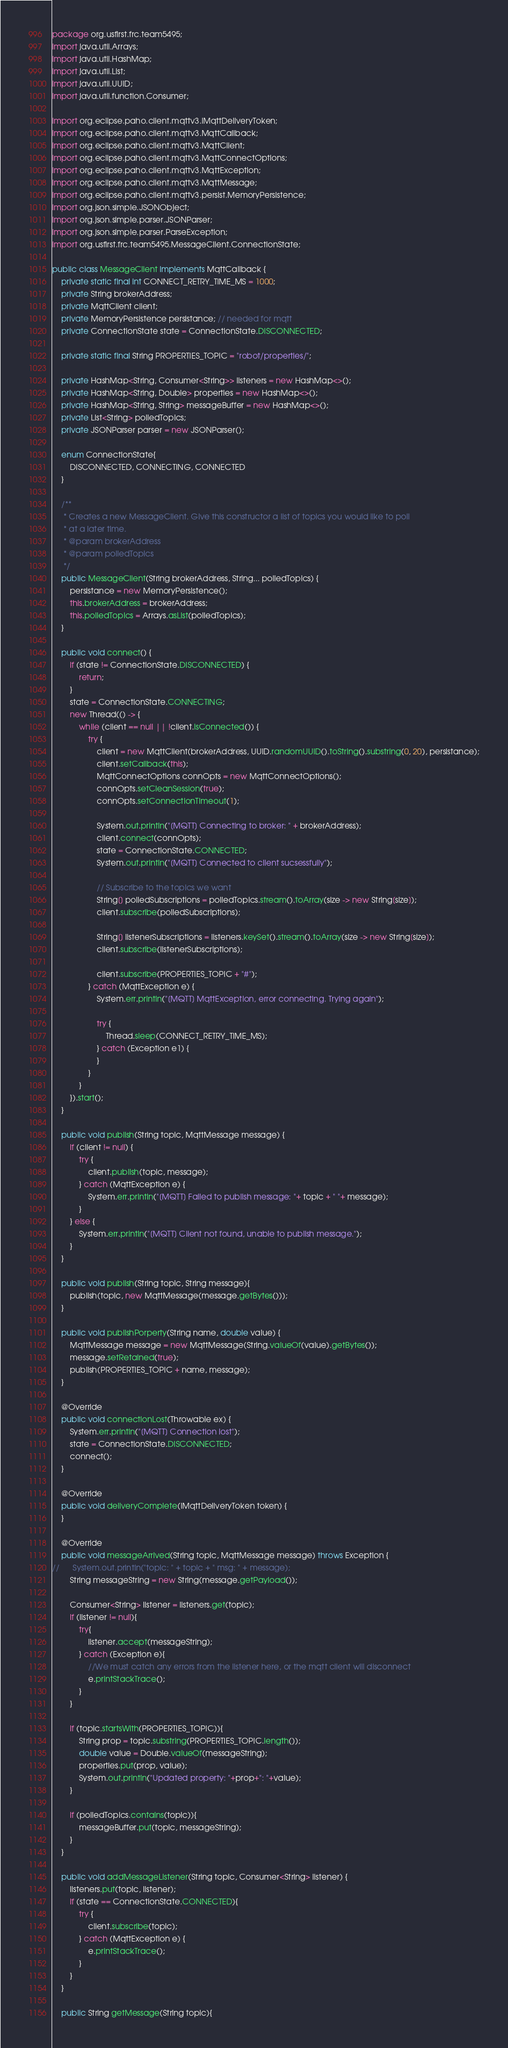<code> <loc_0><loc_0><loc_500><loc_500><_Java_>package org.usfirst.frc.team5495;
import java.util.Arrays;
import java.util.HashMap;
import java.util.List;
import java.util.UUID;
import java.util.function.Consumer;

import org.eclipse.paho.client.mqttv3.IMqttDeliveryToken;
import org.eclipse.paho.client.mqttv3.MqttCallback;
import org.eclipse.paho.client.mqttv3.MqttClient;
import org.eclipse.paho.client.mqttv3.MqttConnectOptions;
import org.eclipse.paho.client.mqttv3.MqttException;
import org.eclipse.paho.client.mqttv3.MqttMessage;
import org.eclipse.paho.client.mqttv3.persist.MemoryPersistence;
import org.json.simple.JSONObject;
import org.json.simple.parser.JSONParser;
import org.json.simple.parser.ParseException;
import org.usfirst.frc.team5495.MessageClient.ConnectionState;

public class MessageClient implements MqttCallback {
	private static final int CONNECT_RETRY_TIME_MS = 1000;
	private String brokerAddress;
	private MqttClient client;
	private MemoryPersistence persistance; // needed for mqtt
	private ConnectionState state = ConnectionState.DISCONNECTED;
	
	private static final String PROPERTIES_TOPIC = "robot/properties/";
	
	private HashMap<String, Consumer<String>> listeners = new HashMap<>();
	private HashMap<String, Double> properties = new HashMap<>();
	private HashMap<String, String> messageBuffer = new HashMap<>();
	private List<String> polledTopics;
	private JSONParser parser = new JSONParser();

	enum ConnectionState{
		DISCONNECTED, CONNECTING, CONNECTED
	}
	
	/**
	 * Creates a new MessageClient. Give this constructor a list of topics you would like to poll 
	 * at a later time.
	 * @param brokerAddress
	 * @param polledTopics
	 */
	public MessageClient(String brokerAddress, String... polledTopics) {
		persistance = new MemoryPersistence();
		this.brokerAddress = brokerAddress;
		this.polledTopics = Arrays.asList(polledTopics);
	}

	public void connect() {
		if (state != ConnectionState.DISCONNECTED) {
			return;
		}
		state = ConnectionState.CONNECTING;
		new Thread(() -> {
			while (client == null || !client.isConnected()) {
				try {
					client = new MqttClient(brokerAddress, UUID.randomUUID().toString().substring(0, 20), persistance);
					client.setCallback(this);
					MqttConnectOptions connOpts = new MqttConnectOptions();
					connOpts.setCleanSession(true);
					connOpts.setConnectionTimeout(1);
					
					System.out.println("[MQTT] Connecting to broker: " + brokerAddress);
					client.connect(connOpts);
					state = ConnectionState.CONNECTED;
					System.out.println("[MQTT] Connected to client sucsessfully");

					// Subscribe to the topics we want
					String[] polledSubscriptions = polledTopics.stream().toArray(size -> new String[size]);
					client.subscribe(polledSubscriptions);
					
					String[] listenerSubscriptions = listeners.keySet().stream().toArray(size -> new String[size]);
					client.subscribe(listenerSubscriptions);

					client.subscribe(PROPERTIES_TOPIC + "#");
				} catch (MqttException e) {
					System.err.println("[MQTT] MqttException, error connecting. Trying again");
					
					try {
						Thread.sleep(CONNECT_RETRY_TIME_MS);
					} catch (Exception e1) {
					}
				}
			}
		}).start();
	}

	public void publish(String topic, MqttMessage message) {
		if (client != null) {
			try {
				client.publish(topic, message);
			} catch (MqttException e) {
				System.err.println("[MQTT] Failed to publish message: "+ topic + " "+ message);
			}
		} else {
			System.err.println("[MQTT] Client not found, unable to publish message.");
		}
	}
	
	public void publish(String topic, String message){
		publish(topic, new MqttMessage(message.getBytes()));
	}

	public void publishPorperty(String name, double value) {
		MqttMessage message = new MqttMessage(String.valueOf(value).getBytes());
		message.setRetained(true);
		publish(PROPERTIES_TOPIC + name, message);  
	}
	
	@Override
	public void connectionLost(Throwable ex) {
		System.err.println("[MQTT] Connection lost");
		state = ConnectionState.DISCONNECTED;
		connect();
	}

	@Override
	public void deliveryComplete(IMqttDeliveryToken token) {	
	}

	@Override
	public void messageArrived(String topic, MqttMessage message) throws Exception {
//		System.out.println("topic: " + topic + " msg: " + message);
		String messageString = new String(message.getPayload());
		
		Consumer<String> listener = listeners.get(topic);
		if (listener != null){
			try{
				listener.accept(messageString);
			} catch (Exception e){
				//We must catch any errors from the listener here, or the mqtt client will disconnect
				e.printStackTrace();
			}
		}
		
		if (topic.startsWith(PROPERTIES_TOPIC)){
			String prop = topic.substring(PROPERTIES_TOPIC.length());
			double value = Double.valueOf(messageString);
			properties.put(prop, value);
			System.out.println("Updated property: "+prop+": "+value);
		}
		
		if (polledTopics.contains(topic)){
			messageBuffer.put(topic, messageString);
		}
	}
	
	public void addMessageListener(String topic, Consumer<String> listener) {
		listeners.put(topic, listener);
		if (state == ConnectionState.CONNECTED){
			try {
				client.subscribe(topic);
			} catch (MqttException e) {
				e.printStackTrace();
			}
		}
	}
	
	public String getMessage(String topic){</code> 